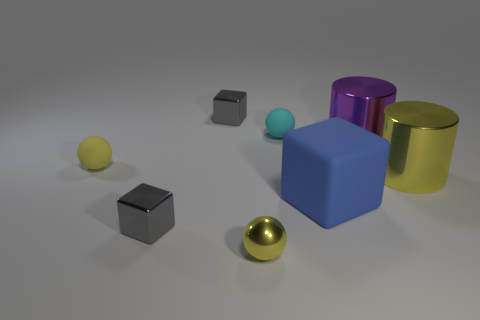Is the material of the blue thing the same as the large yellow object?
Provide a short and direct response. No. What number of blocks are either big purple shiny things or yellow rubber objects?
Ensure brevity in your answer.  0. There is a small object that is the same material as the cyan sphere; what is its color?
Keep it short and to the point. Yellow. Are there fewer tiny metallic cubes than large yellow metal cylinders?
Your response must be concise. No. There is a yellow thing to the right of the purple thing; is it the same shape as the yellow thing that is behind the yellow metallic cylinder?
Ensure brevity in your answer.  No. How many things are either large metal objects or big blue cylinders?
Your answer should be compact. 2. There is a matte ball that is the same size as the cyan object; what color is it?
Your answer should be compact. Yellow. There is a small gray shiny cube that is in front of the big yellow cylinder; how many tiny yellow metallic objects are to the left of it?
Your response must be concise. 0. What number of shiny things are behind the small yellow metallic sphere and left of the big yellow cylinder?
Your answer should be very brief. 3. How many objects are either yellow shiny objects to the left of the big blue rubber thing or yellow things that are on the left side of the large matte block?
Your answer should be compact. 2. 